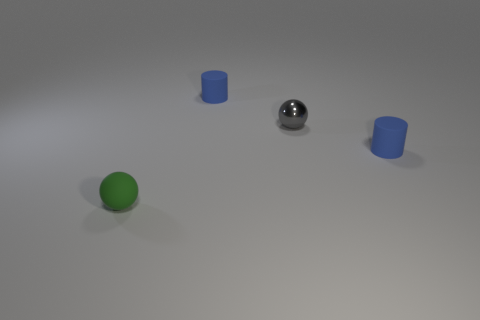What number of large purple cylinders are there?
Your answer should be very brief. 0. Are the gray ball and the green object on the left side of the gray metal sphere made of the same material?
Your answer should be very brief. No. How many green objects are either matte cylinders or big objects?
Offer a terse response. 0. What number of other objects have the same shape as the metallic thing?
Your answer should be very brief. 1. Are there more blue cylinders that are left of the rubber sphere than matte things that are in front of the small metal sphere?
Make the answer very short. No. Do the small metallic sphere and the tiny object on the right side of the gray metal sphere have the same color?
Your answer should be very brief. No. There is another green object that is the same size as the shiny object; what is it made of?
Offer a very short reply. Rubber. How many objects are either purple things or tiny rubber cylinders in front of the gray ball?
Give a very brief answer. 1. There is a shiny thing; is its size the same as the matte thing behind the metal sphere?
Your response must be concise. Yes. What number of balls are green matte objects or shiny things?
Give a very brief answer. 2. 